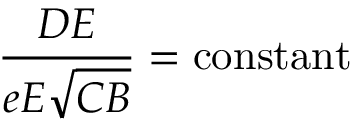<formula> <loc_0><loc_0><loc_500><loc_500>{ \frac { D E } { e E { \sqrt { C B } } } } = { c o n s t a n t }</formula> 